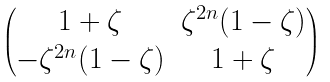Convert formula to latex. <formula><loc_0><loc_0><loc_500><loc_500>\begin{pmatrix} 1 + \zeta & \zeta ^ { 2 n } ( 1 - \zeta ) \\ - \zeta ^ { 2 n } ( 1 - \zeta ) & 1 + \zeta \end{pmatrix}</formula> 